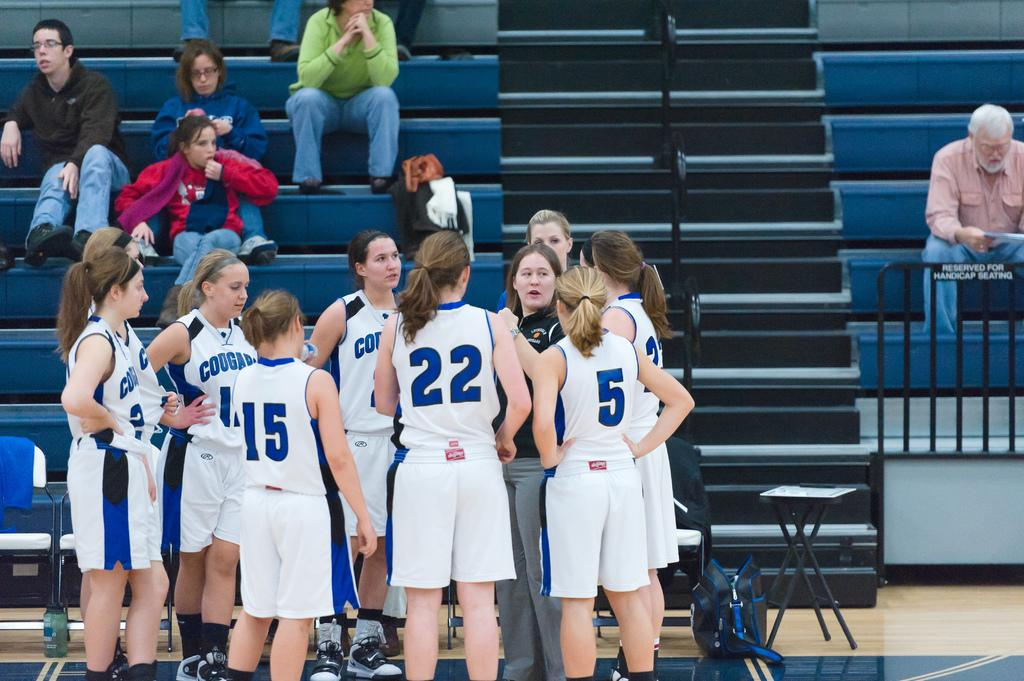<image>
Provide a brief description of the given image. A girl with the number 22 on the back of her jersey is standing with her team. 